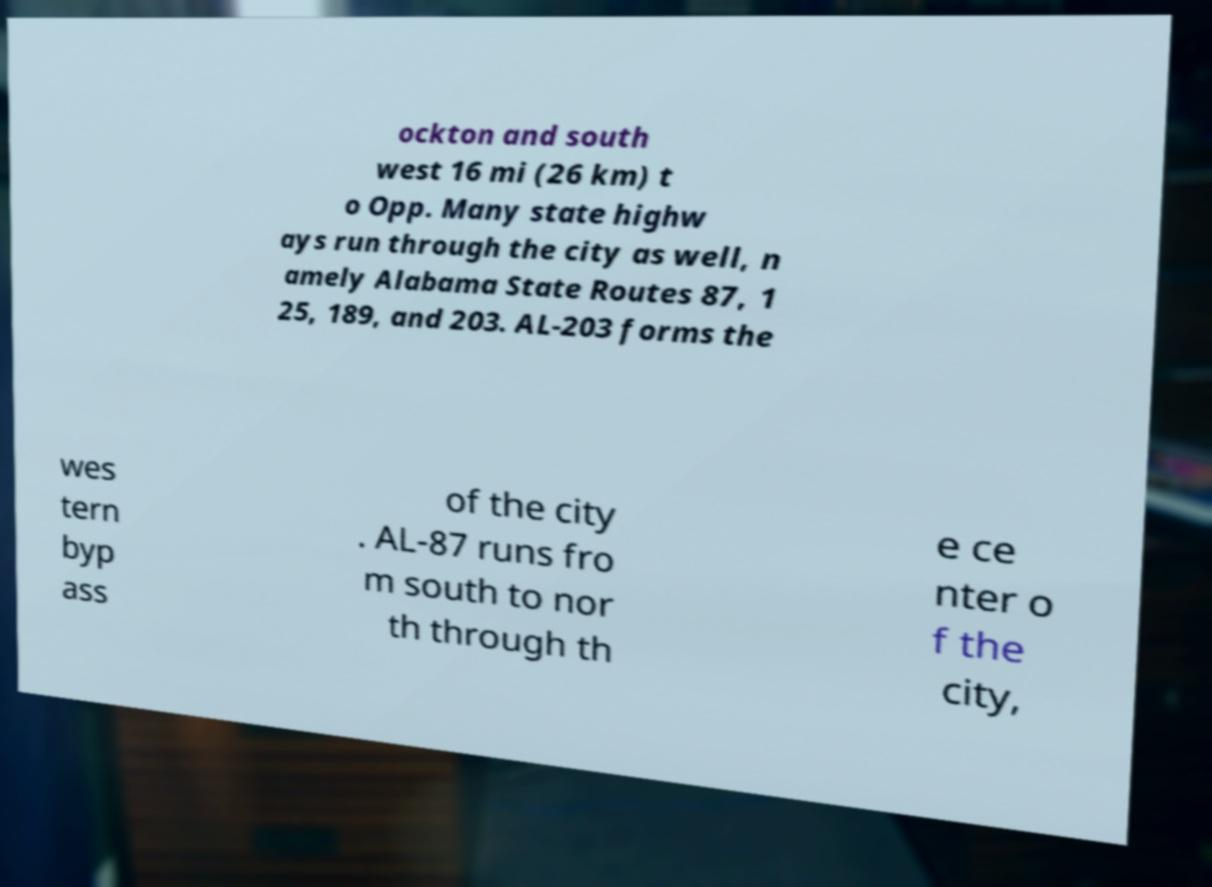What messages or text are displayed in this image? I need them in a readable, typed format. ockton and south west 16 mi (26 km) t o Opp. Many state highw ays run through the city as well, n amely Alabama State Routes 87, 1 25, 189, and 203. AL-203 forms the wes tern byp ass of the city . AL-87 runs fro m south to nor th through th e ce nter o f the city, 